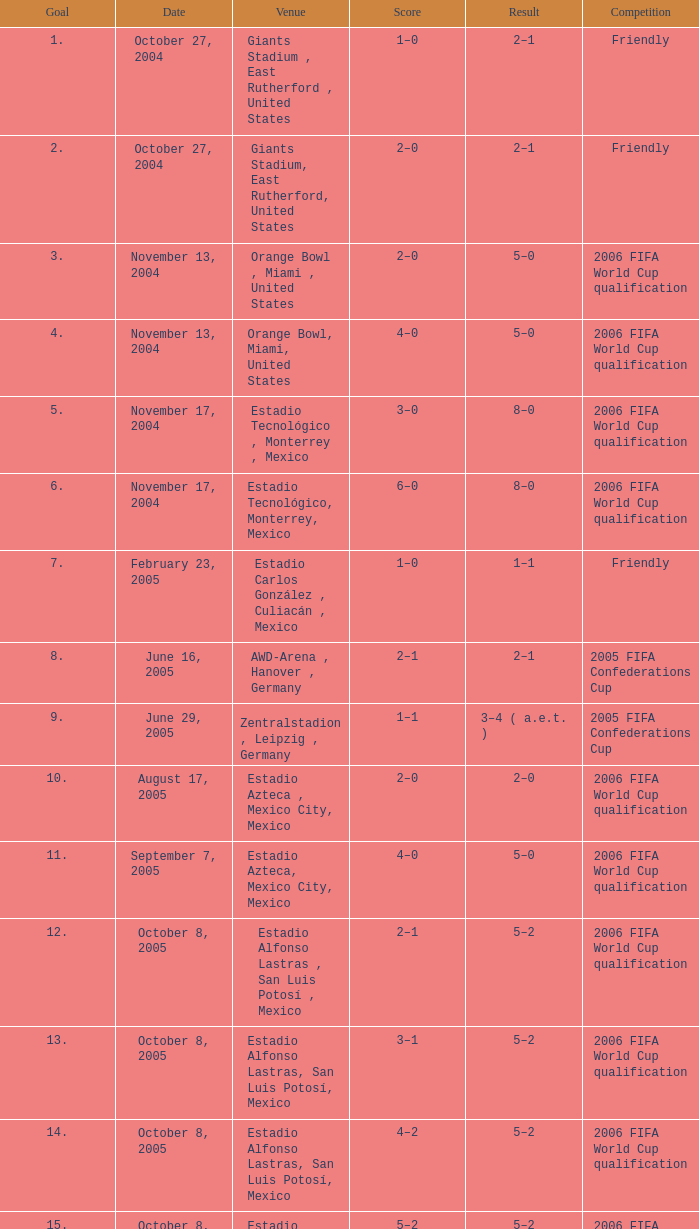Which score has a result of 2-1, and a match of friendly, and a goal smaller than 17? 1–0, 2–0. 